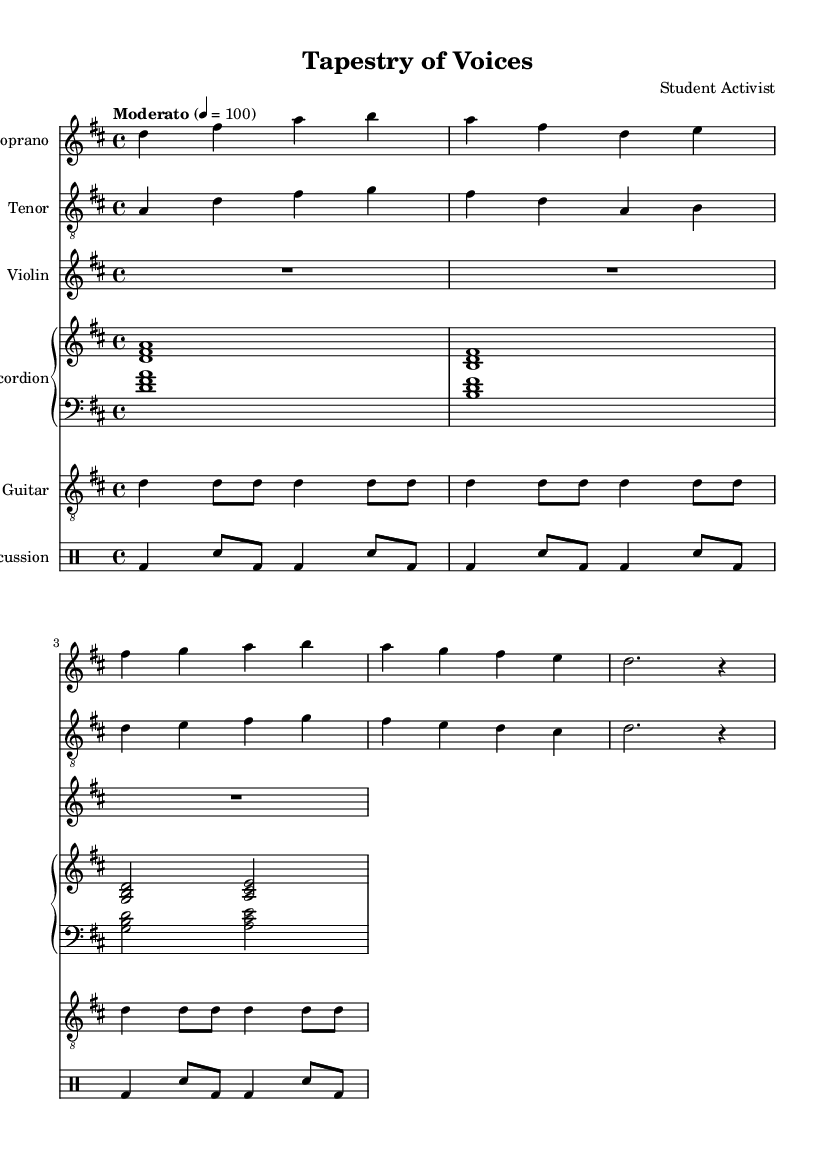What is the key signature of this music? The key signature is indicated at the beginning of the score. It shows two sharps, which correspond to F sharp and C sharp, identifying the key as D major.
Answer: D major What is the time signature of this opera? The time signature is shown at the start of the score, represented by 4/4, which means there are four beats in each measure and a quarter note gets one beat.
Answer: 4/4 What is the tempo marking for this piece? The tempo is specified as "Moderato" with a metronome marking of 100, indicating a moderate speed for performance.
Answer: Moderato 100 What instruments are included in the score? By analyzing the score, we see various instrument parts: Soprano, Tenor, Violin, Accordion, Guitar, and Percussion.
Answer: Soprano, Tenor, Violin, Accordion, Guitar, Percussion Which voice part has the highest pitch range in this piece? The Soprano part is typically the highest voice in choral and operatic music. By examining the respective ranges of the voice parts, the Soprano consistently is written higher than the Tenor.
Answer: Soprano What is the thematic focus of the lyrics in this opera? The lyrics suggest a celebration of cultural diversity and immigrant experiences, indicating a narrative based on the journey and stories brought from distant places. This is derived from the opening lines of the lyrics.
Answer: Cultural diversity and immigrant experiences How many measures are present in the Soprano part? Counting the individual measure segments in the Soprano line, there are a total of three measures completed.
Answer: Three measures 